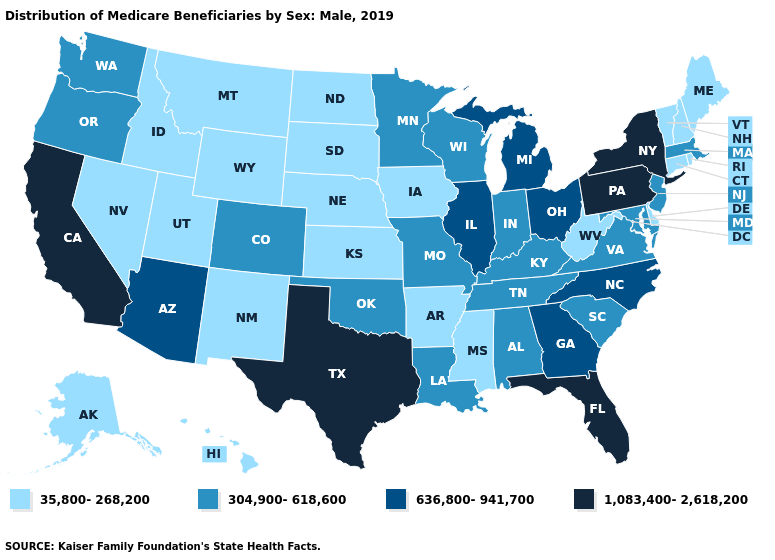Name the states that have a value in the range 304,900-618,600?
Write a very short answer. Alabama, Colorado, Indiana, Kentucky, Louisiana, Maryland, Massachusetts, Minnesota, Missouri, New Jersey, Oklahoma, Oregon, South Carolina, Tennessee, Virginia, Washington, Wisconsin. Does the first symbol in the legend represent the smallest category?
Be succinct. Yes. Which states have the highest value in the USA?
Keep it brief. California, Florida, New York, Pennsylvania, Texas. What is the lowest value in states that border Wisconsin?
Be succinct. 35,800-268,200. Which states hav the highest value in the Northeast?
Answer briefly. New York, Pennsylvania. Which states have the lowest value in the South?
Quick response, please. Arkansas, Delaware, Mississippi, West Virginia. Name the states that have a value in the range 304,900-618,600?
Quick response, please. Alabama, Colorado, Indiana, Kentucky, Louisiana, Maryland, Massachusetts, Minnesota, Missouri, New Jersey, Oklahoma, Oregon, South Carolina, Tennessee, Virginia, Washington, Wisconsin. Name the states that have a value in the range 35,800-268,200?
Keep it brief. Alaska, Arkansas, Connecticut, Delaware, Hawaii, Idaho, Iowa, Kansas, Maine, Mississippi, Montana, Nebraska, Nevada, New Hampshire, New Mexico, North Dakota, Rhode Island, South Dakota, Utah, Vermont, West Virginia, Wyoming. Does Illinois have the highest value in the MidWest?
Be succinct. Yes. Does the first symbol in the legend represent the smallest category?
Give a very brief answer. Yes. Does Nebraska have the highest value in the MidWest?
Quick response, please. No. Is the legend a continuous bar?
Give a very brief answer. No. What is the lowest value in states that border Arizona?
Write a very short answer. 35,800-268,200. What is the value of Minnesota?
Answer briefly. 304,900-618,600. What is the value of Louisiana?
Short answer required. 304,900-618,600. 